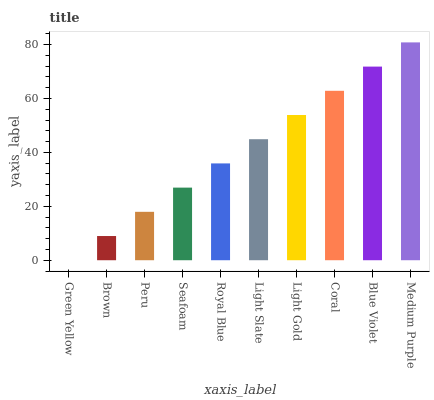Is Green Yellow the minimum?
Answer yes or no. Yes. Is Medium Purple the maximum?
Answer yes or no. Yes. Is Brown the minimum?
Answer yes or no. No. Is Brown the maximum?
Answer yes or no. No. Is Brown greater than Green Yellow?
Answer yes or no. Yes. Is Green Yellow less than Brown?
Answer yes or no. Yes. Is Green Yellow greater than Brown?
Answer yes or no. No. Is Brown less than Green Yellow?
Answer yes or no. No. Is Light Slate the high median?
Answer yes or no. Yes. Is Royal Blue the low median?
Answer yes or no. Yes. Is Green Yellow the high median?
Answer yes or no. No. Is Peru the low median?
Answer yes or no. No. 